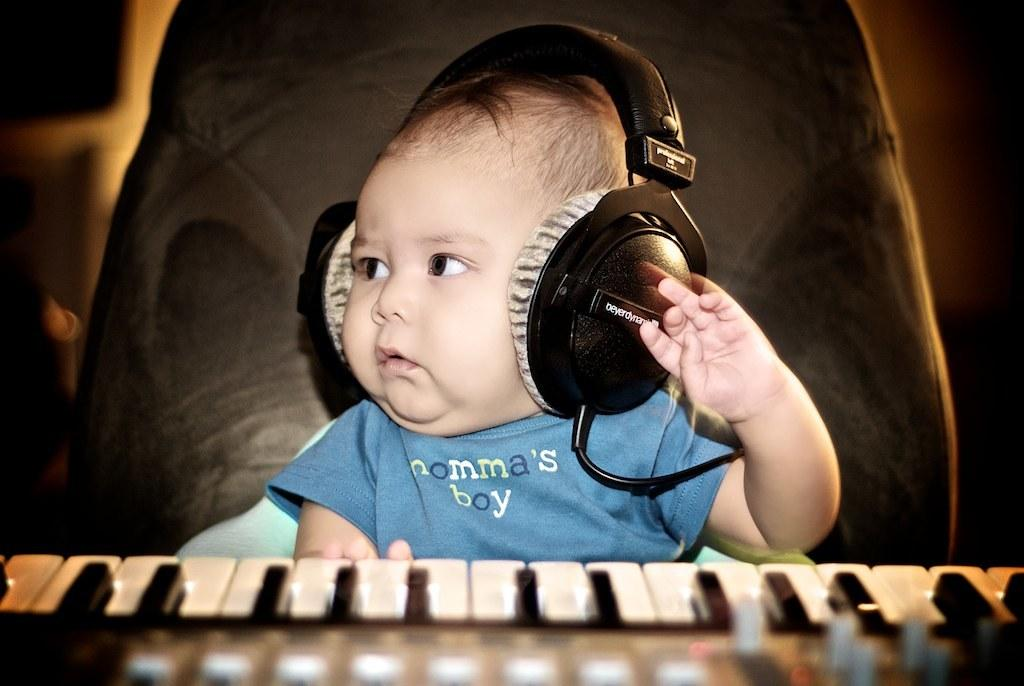Who is the main subject in the image? There is a little boy in the image. What is the boy wearing on his ears? The boy is wearing headphones. What is written on the boy's T-shirt? The boy is wearing a blue T-shirt with the label "mama's boy". What is the boy sitting in front of? The boy is sitting in front of a keyboard. What direction is the boy looking in? The boy is looking to the side. What action is the boy performing with his hand? The boy is raising his hand. What type of vessel is the boy using to plough the field in the image? There is no vessel or ploughing activity present in the image. 